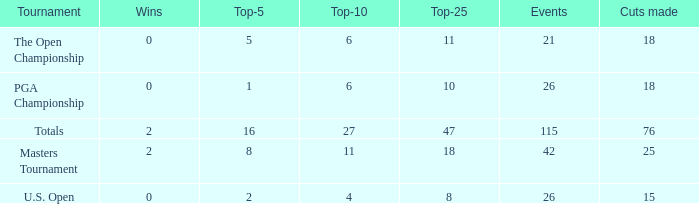When the wins are less than 0 and the Top-5 1 what is the average cuts? None. 